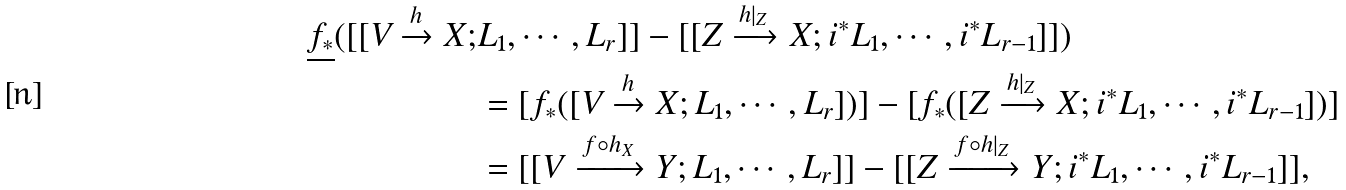<formula> <loc_0><loc_0><loc_500><loc_500>\underline { f _ { * } } ( [ [ V \xrightarrow h X ; & L _ { 1 } , \cdots , L _ { r } ] ] - [ [ Z \xrightarrow { h | _ { Z } } X ; i ^ { * } L _ { 1 } , \cdots , i ^ { * } L _ { r - 1 } ] ] ) \\ & = [ f _ { * } ( [ V \xrightarrow h X ; L _ { 1 } , \cdots , L _ { r } ] ) ] - [ f _ { * } ( [ Z \xrightarrow { h | _ { Z } } X ; i ^ { * } L _ { 1 } , \cdots , i ^ { * } L _ { r - 1 } ] ) ] \\ & = [ [ V \xrightarrow { f \circ h _ { X } } Y ; L _ { 1 } , \cdots , L _ { r } ] ] - [ [ Z \xrightarrow { f \circ h | _ { Z } } Y ; i ^ { * } L _ { 1 } , \cdots , i ^ { * } L _ { r - 1 } ] ] ,</formula> 